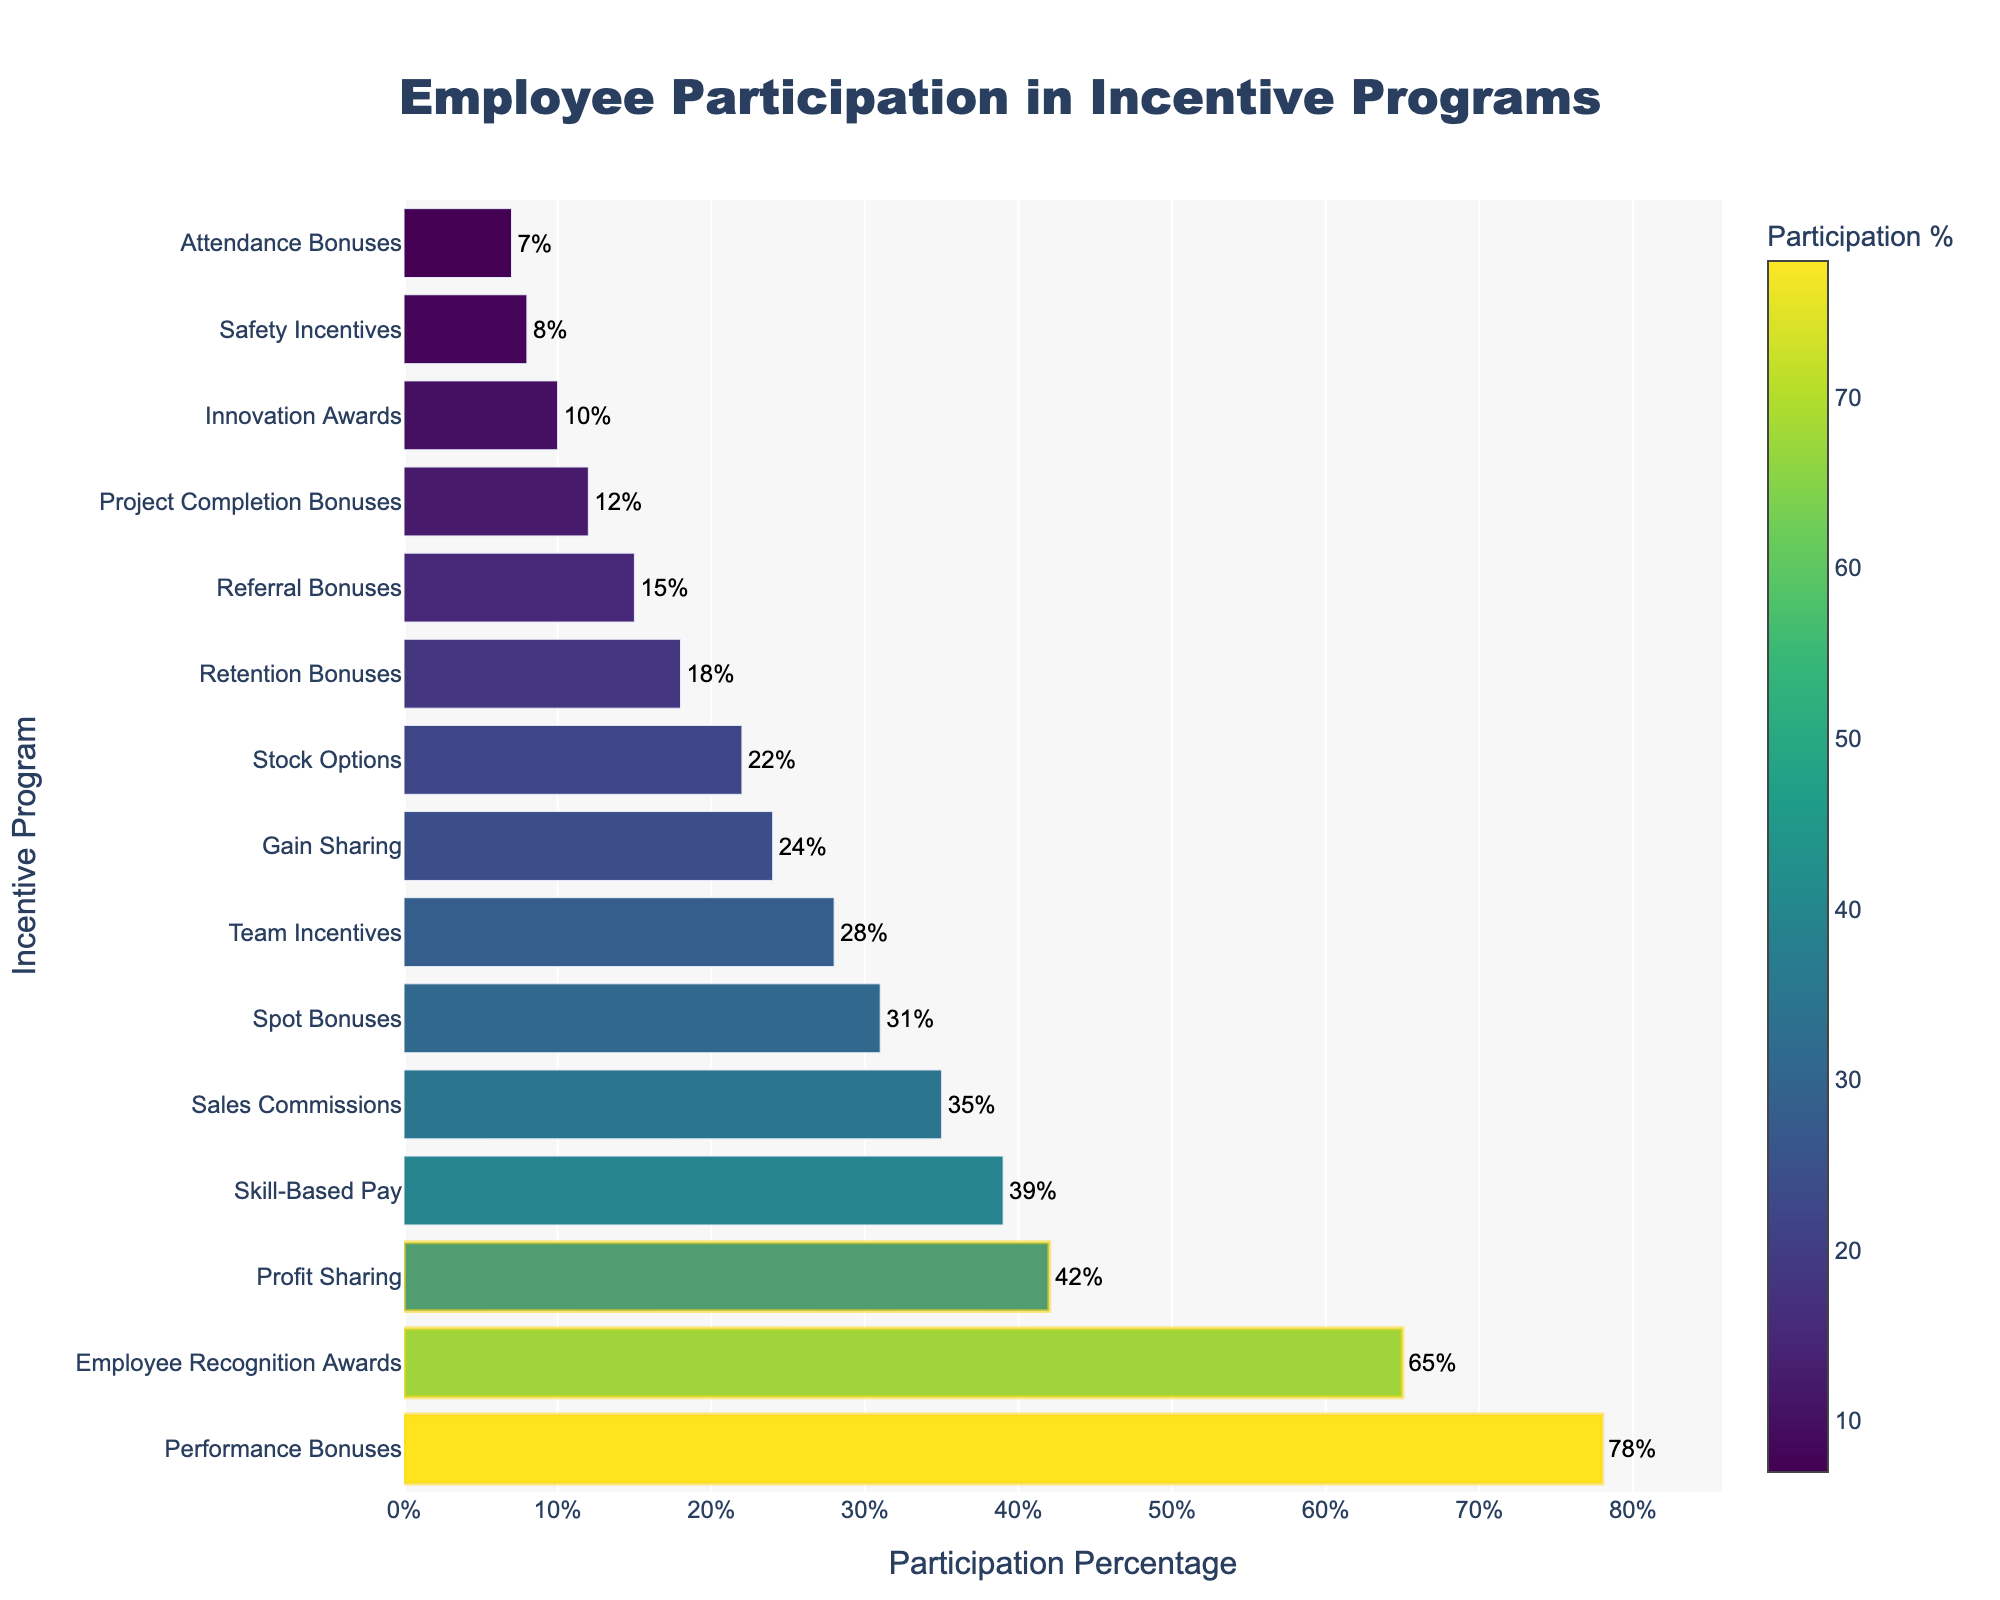Which incentive program has the highest participation percentage? The figure shows the participation percentages of various incentive programs. The highest bar in the chart represents the program with the highest participation percentage.
Answer: Performance Bonuses Which incentive program has the lowest participation percentage? The figure shows the participation percentages of various incentive programs. The lowest bar in the chart represents the program with the lowest participation percentage.
Answer: Attendance Bonuses What is the difference in participation percentage between Performance Bonuses and Skill-Based Pay? Performance Bonuses have a participation percentage of 78% and Skill-Based Pay has 39%. The difference can be calculated by subtracting 39 from 78.
Answer: 39% How does the participation in Team Incentives compare to Safety Incentives? Team Incentives have a participation percentage of 28% while Safety Incentives have 8%. Comparison involves checking which percentage is higher.
Answer: Team Incentives is higher What is the combined participation percentage of the top three incentive programs? The top three incentive programs are Performance Bonuses (78%), Employee Recognition Awards (65%), and Profit Sharing (42%). Summing these values gives the combined participation percentage: 78 + 65 + 42.
Answer: 185% Which incentive programs are highlighted with a rectangle shape in the figure? The top three incentive programs (Performance Bonuses, Employee Recognition Awards, and Profit Sharing) are visually highlighted with a rectangle shape in the figure.
Answer: Performance Bonuses, Employee Recognition Awards, Profit Sharing What is the average participation percentage across all listed incentive programs? Sum all participation percentages and divide by the number of programs. Sum = 78 + 65 + 42 + 39 + 35 + 31 + 28 + 24 + 22 + 18 + 15 + 12 + 10 + 8 + 7 = 434. Number of programs = 15. Average = 434 / 15.
Answer: 28.93% What is the participation percentage range in the figure? The range is calculated by subtracting the smallest percentage from the largest percentage. The largest is 78% (Performance Bonuses) and the smallest is 7% (Attendance Bonuses). Range = 78 - 7.
Answer: 71% Which two incentive programs have the closest participation percentages? By comparing the participation percentages visually, find two bars that are nearly the same height. Skill-Based Pay (39%) and Sales Commissions (35%) are closest.
Answer: Skill-Based Pay and Sales Commissions Is Profit Sharing participation higher or lower than Employee Recognition Awards? Compare the heights of the bars representing Profit Sharing (42%) and Employee Recognition Awards (65%). The bar for Employee Recognition Awards is taller.
Answer: Lower 